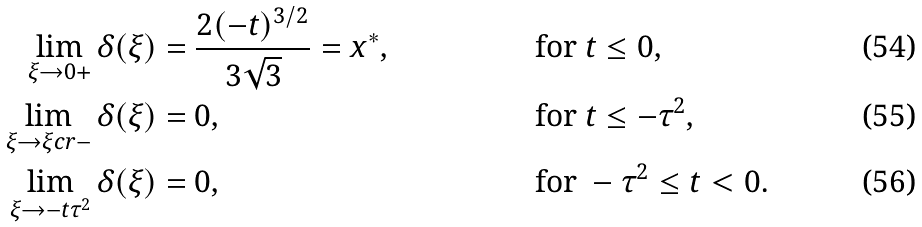Convert formula to latex. <formula><loc_0><loc_0><loc_500><loc_500>\lim _ { \xi \to 0 + } \delta ( \xi ) & = \frac { 2 ( - t ) ^ { 3 / 2 } } { 3 \sqrt { 3 } } = x ^ { * } , & & \text {for } t \leq 0 , \\ \lim _ { \xi \to \xi c r - } \delta ( \xi ) & = 0 , & & \text {for } t \leq - \tau ^ { 2 } , \\ \lim _ { \xi \to - t \tau ^ { 2 } } \delta ( \xi ) & = 0 , & & \text {for } - \tau ^ { 2 } \leq t < 0 .</formula> 